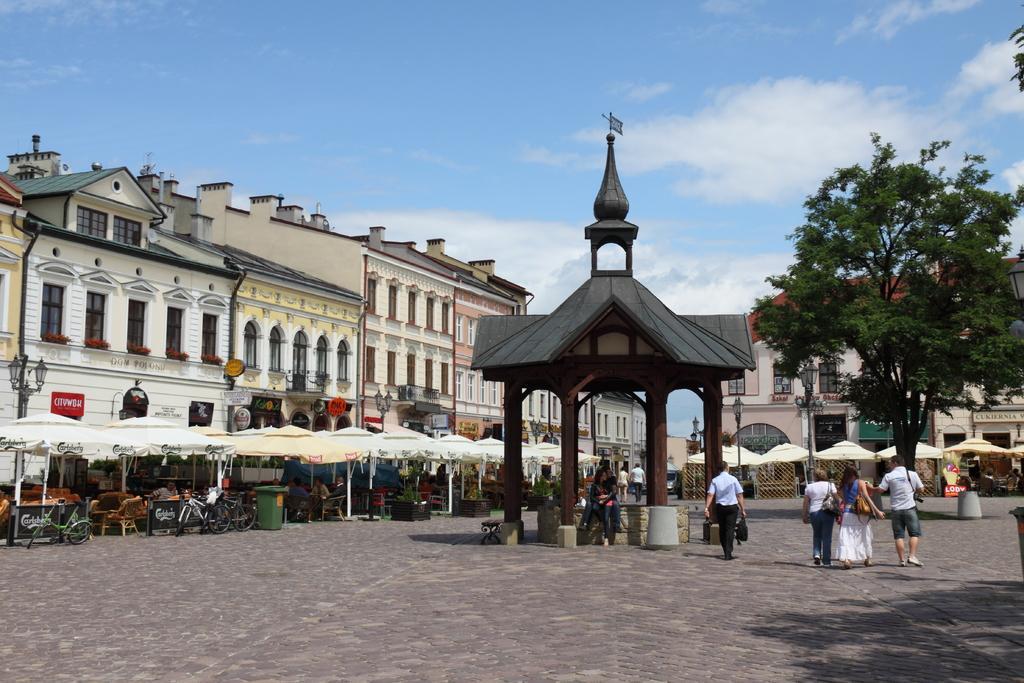How would you summarize this image in a sentence or two? This is an outside view. On the right side, I can see few people are walking on the ground. In the middle of the image there is a shed. Under this two people are sitting. On the left side, I can see few umbrellas, under these few people are sitting on the chairs and also there is a dustbin. In the background I can see few buildings. On the right side there is a tree. At the top I can see the sky and clouds. 